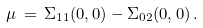Convert formula to latex. <formula><loc_0><loc_0><loc_500><loc_500>\mu \, = \, \Sigma _ { 1 1 } ( 0 , 0 ) - \Sigma _ { 0 2 } ( 0 , 0 ) \, .</formula> 